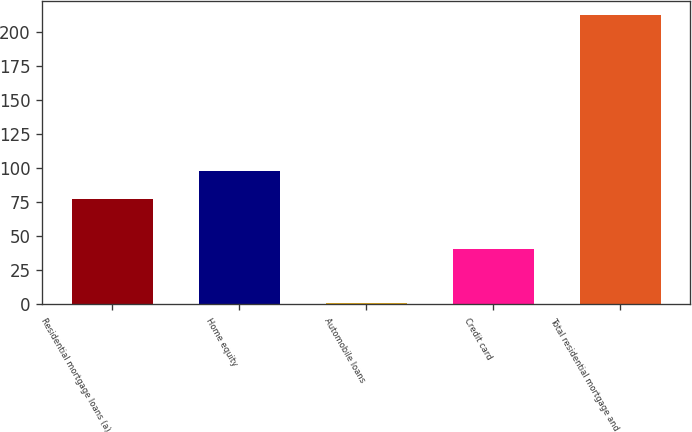Convert chart to OTSL. <chart><loc_0><loc_0><loc_500><loc_500><bar_chart><fcel>Residential mortgage loans (a)<fcel>Home equity<fcel>Automobile loans<fcel>Credit card<fcel>Total residential mortgage and<nl><fcel>77<fcel>98.1<fcel>1<fcel>41<fcel>212<nl></chart> 